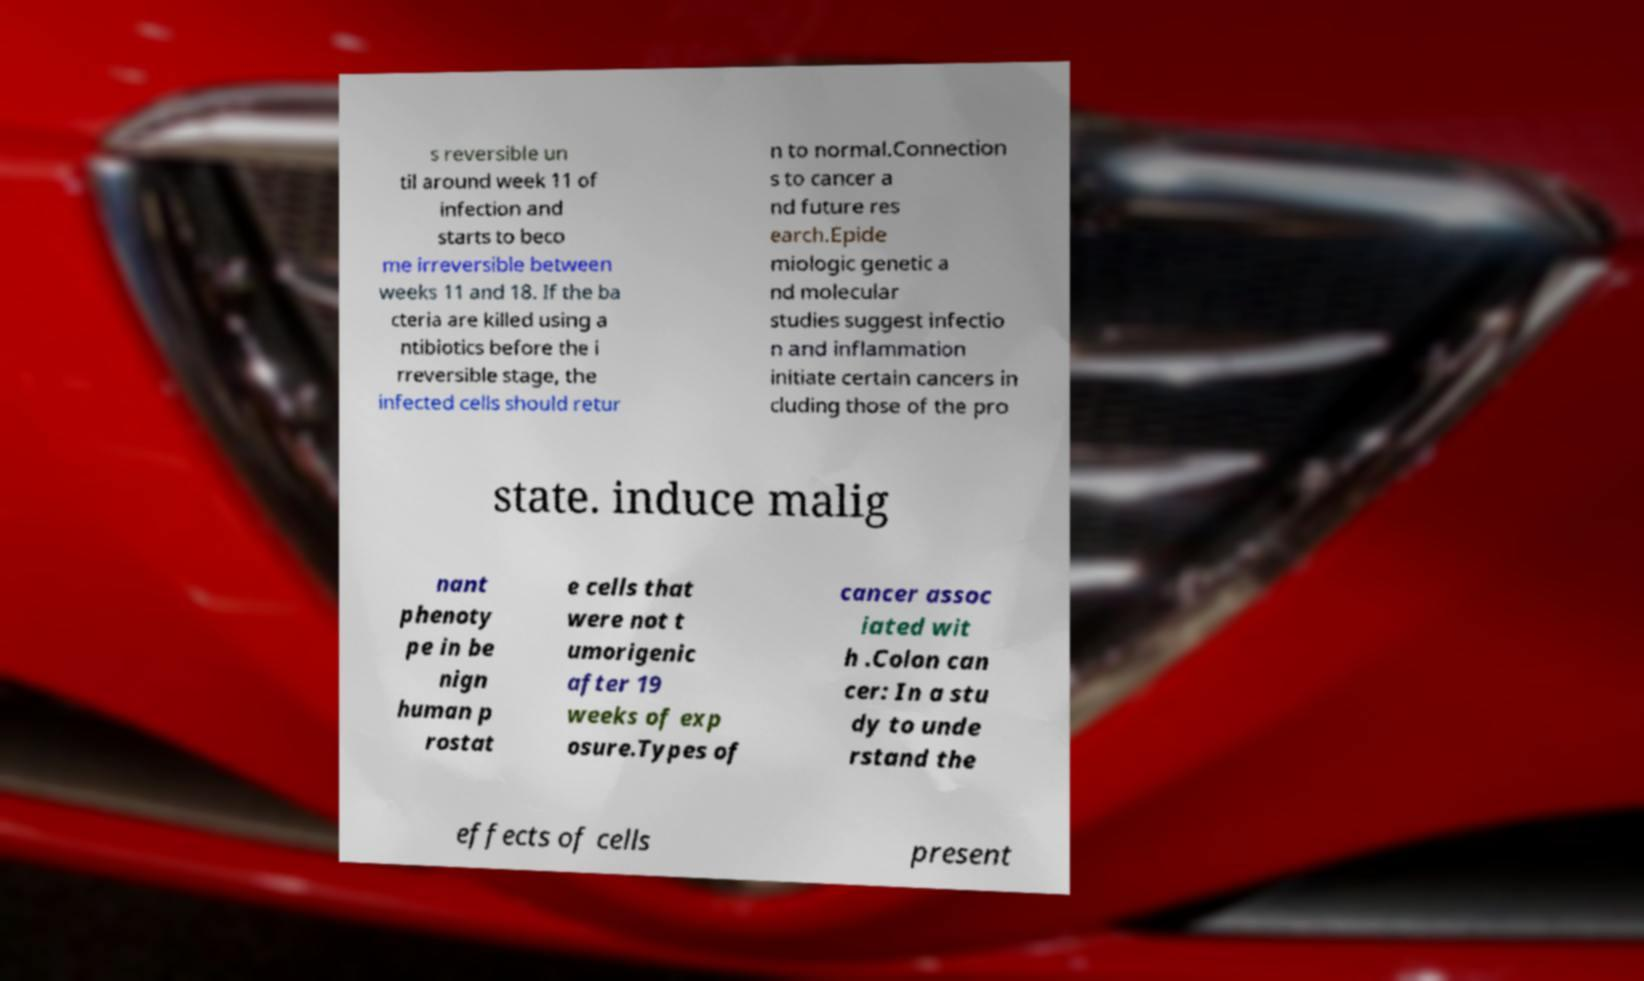Could you assist in decoding the text presented in this image and type it out clearly? s reversible un til around week 11 of infection and starts to beco me irreversible between weeks 11 and 18. If the ba cteria are killed using a ntibiotics before the i rreversible stage, the infected cells should retur n to normal.Connection s to cancer a nd future res earch.Epide miologic genetic a nd molecular studies suggest infectio n and inflammation initiate certain cancers in cluding those of the pro state. induce malig nant phenoty pe in be nign human p rostat e cells that were not t umorigenic after 19 weeks of exp osure.Types of cancer assoc iated wit h .Colon can cer: In a stu dy to unde rstand the effects of cells present 